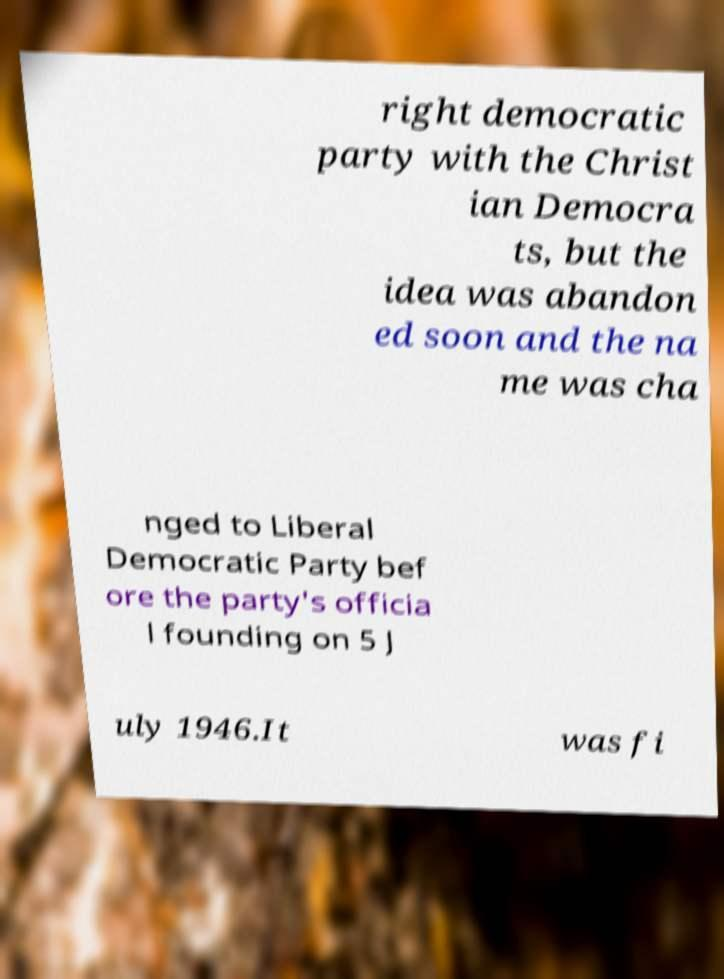For documentation purposes, I need the text within this image transcribed. Could you provide that? right democratic party with the Christ ian Democra ts, but the idea was abandon ed soon and the na me was cha nged to Liberal Democratic Party bef ore the party's officia l founding on 5 J uly 1946.It was fi 